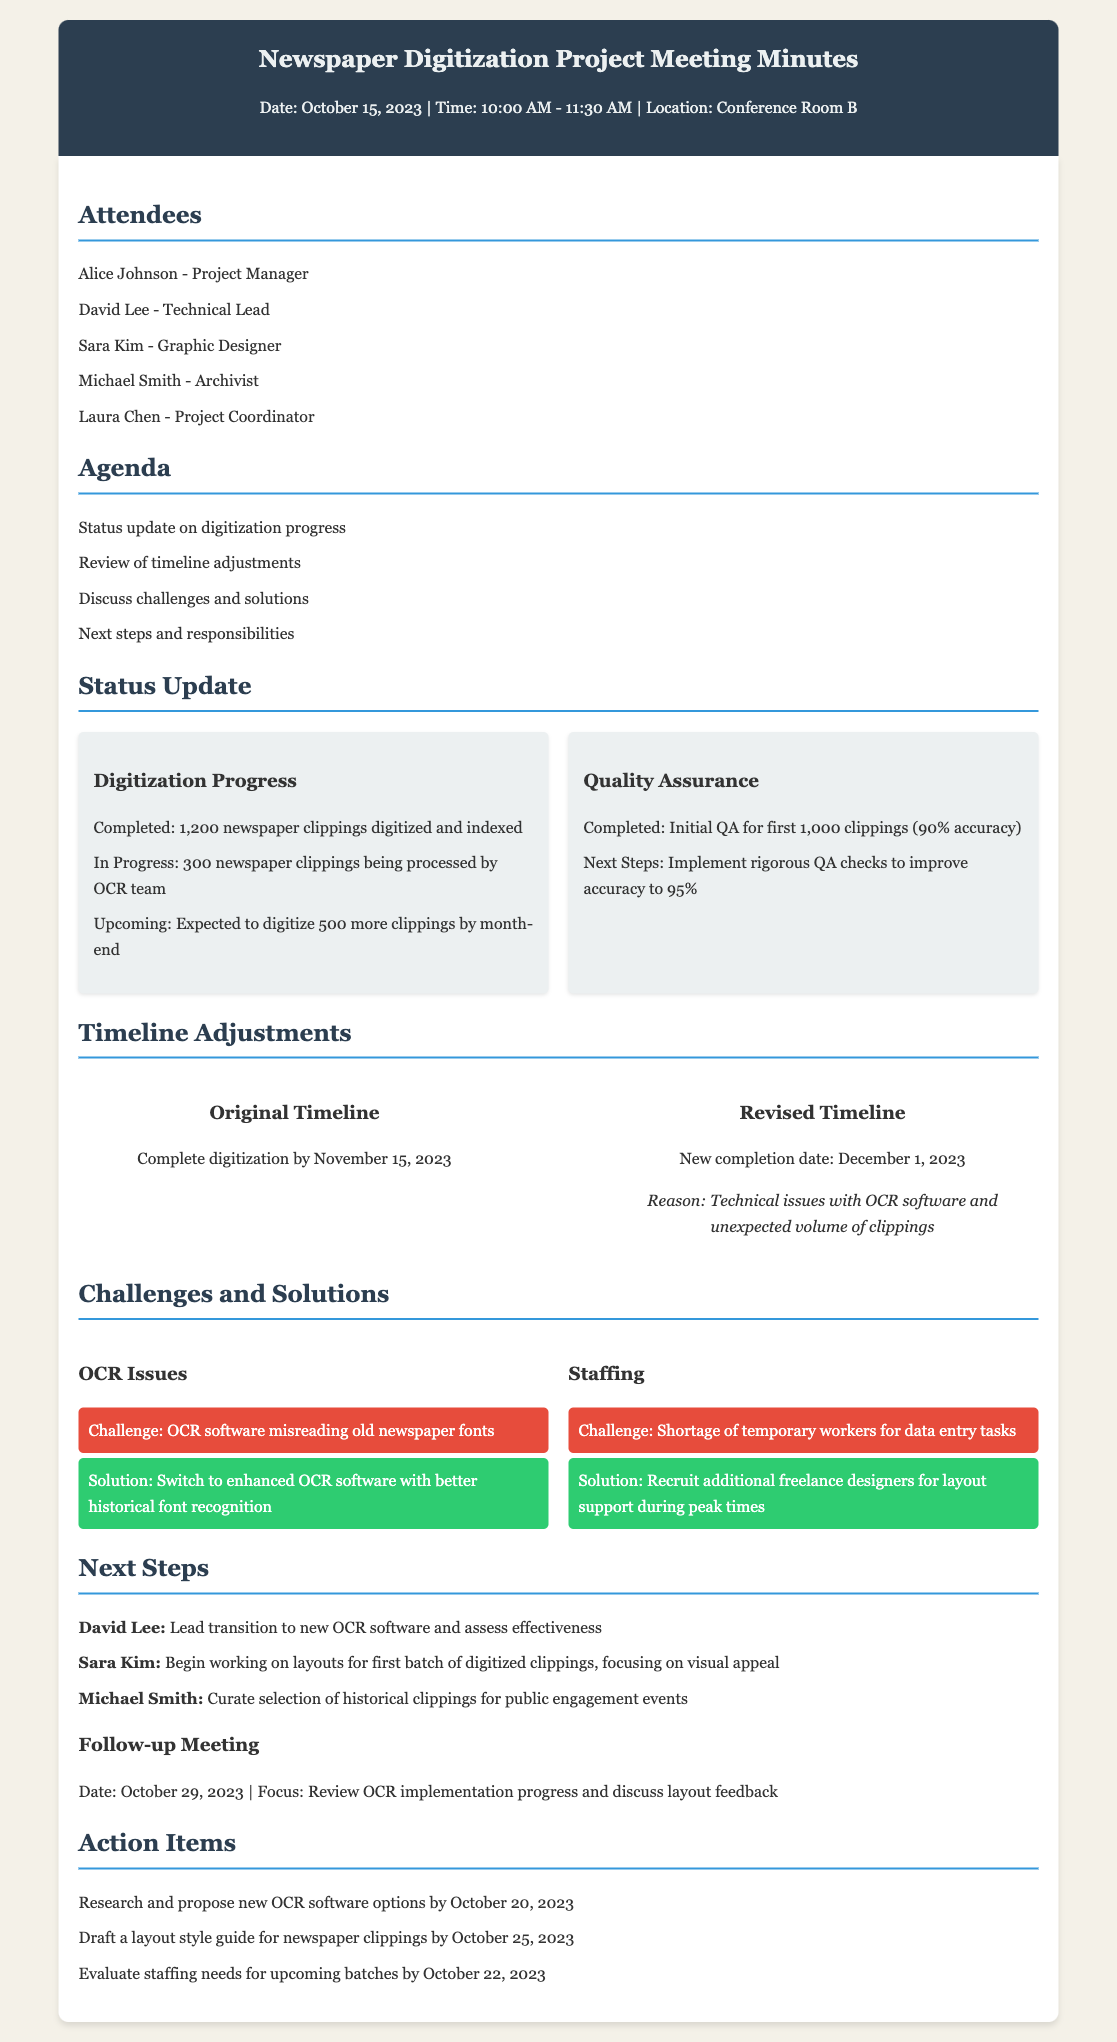What is the date of the meeting? The meeting date is stated in the header section of the document.
Answer: October 15, 2023 Who is the Project Manager? The name of the Project Manager is listed in the attendees section.
Answer: Alice Johnson How many newspaper clippings were completed? The number of completed clippings is mentioned in the digitization progress section.
Answer: 1,200 What is the new completion date for the digitization project? The revised completion date is provided in the timeline adjustments section.
Answer: December 1, 2023 What challenge is associated with the OCR software? The specific challenge faced is outlined in the challenges section regarding the OCR issues.
Answer: Misreading old newspaper fonts What solution is proposed for staffing issues? The solution for addressing staffing shortages is given in the challenges and solutions section.
Answer: Recruit additional freelance designers What is the focus of the follow-up meeting? The focus of the follow-up meeting is stated towards the end of the document.
Answer: Review OCR implementation progress Who is responsible for drafting a layout style guide? The action item specifying who is responsible for this task is listed in the action items section.
Answer: Sara Kim 